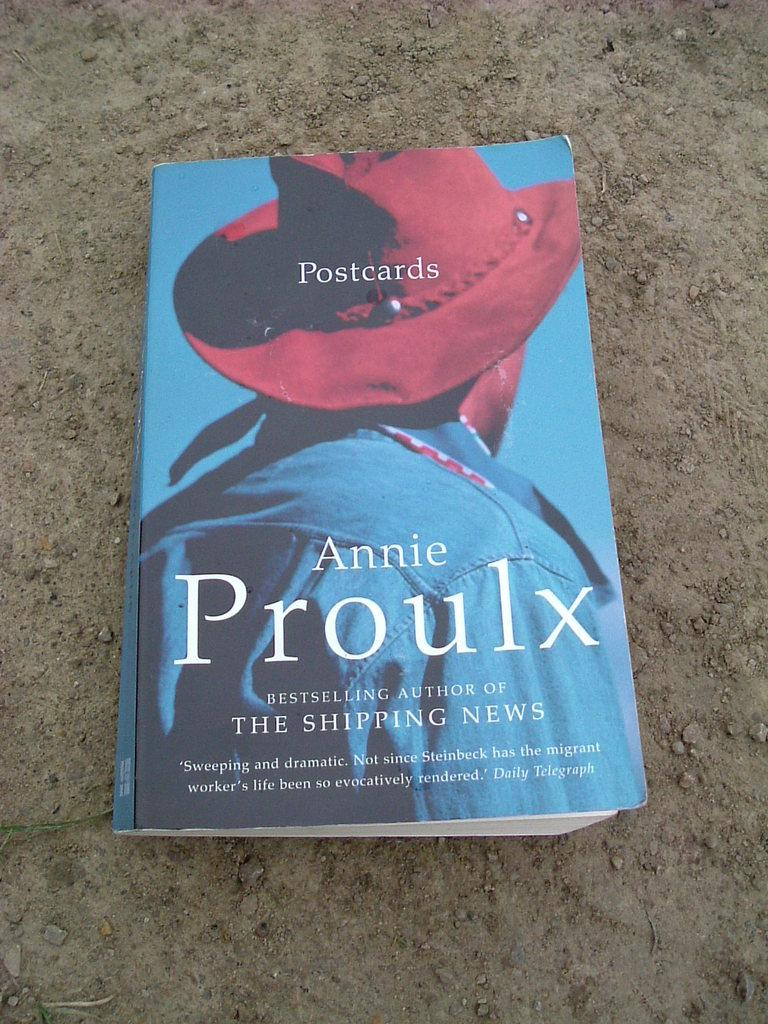<image>
Summarize the visual content of the image. A book by Annie Proulx has a person in a red hat on it. 